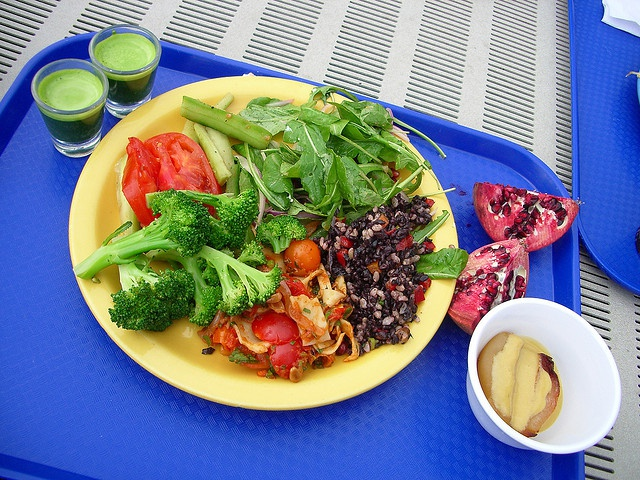Describe the objects in this image and their specific colors. I can see dining table in gray, lightgray, darkgray, and black tones, bowl in gray, lavender, khaki, and tan tones, broccoli in gray, darkgreen, green, and lightgreen tones, cup in gray, lightgreen, and black tones, and cup in gray, lightgreen, black, and darkgray tones in this image. 